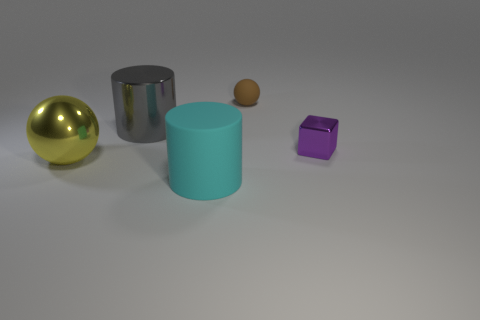Do the cylinder to the right of the gray object and the brown ball have the same material?
Your response must be concise. Yes. What shape is the tiny brown thing?
Provide a succinct answer. Sphere. How many tiny brown objects are on the right side of the cylinder to the right of the cylinder that is behind the big cyan matte object?
Offer a terse response. 1. How many other objects are the same material as the large sphere?
Ensure brevity in your answer.  2. There is a purple object that is the same size as the brown ball; what is its material?
Provide a short and direct response. Metal. There is a rubber thing that is in front of the matte ball; is it the same color as the cylinder behind the big yellow shiny object?
Offer a very short reply. No. Are there any blue metal things that have the same shape as the large rubber thing?
Your answer should be compact. No. There is a gray thing that is the same size as the cyan thing; what is its shape?
Your response must be concise. Cylinder. What number of blocks are the same color as the small ball?
Provide a short and direct response. 0. What size is the matte thing that is in front of the big gray metal cylinder?
Ensure brevity in your answer.  Large. 